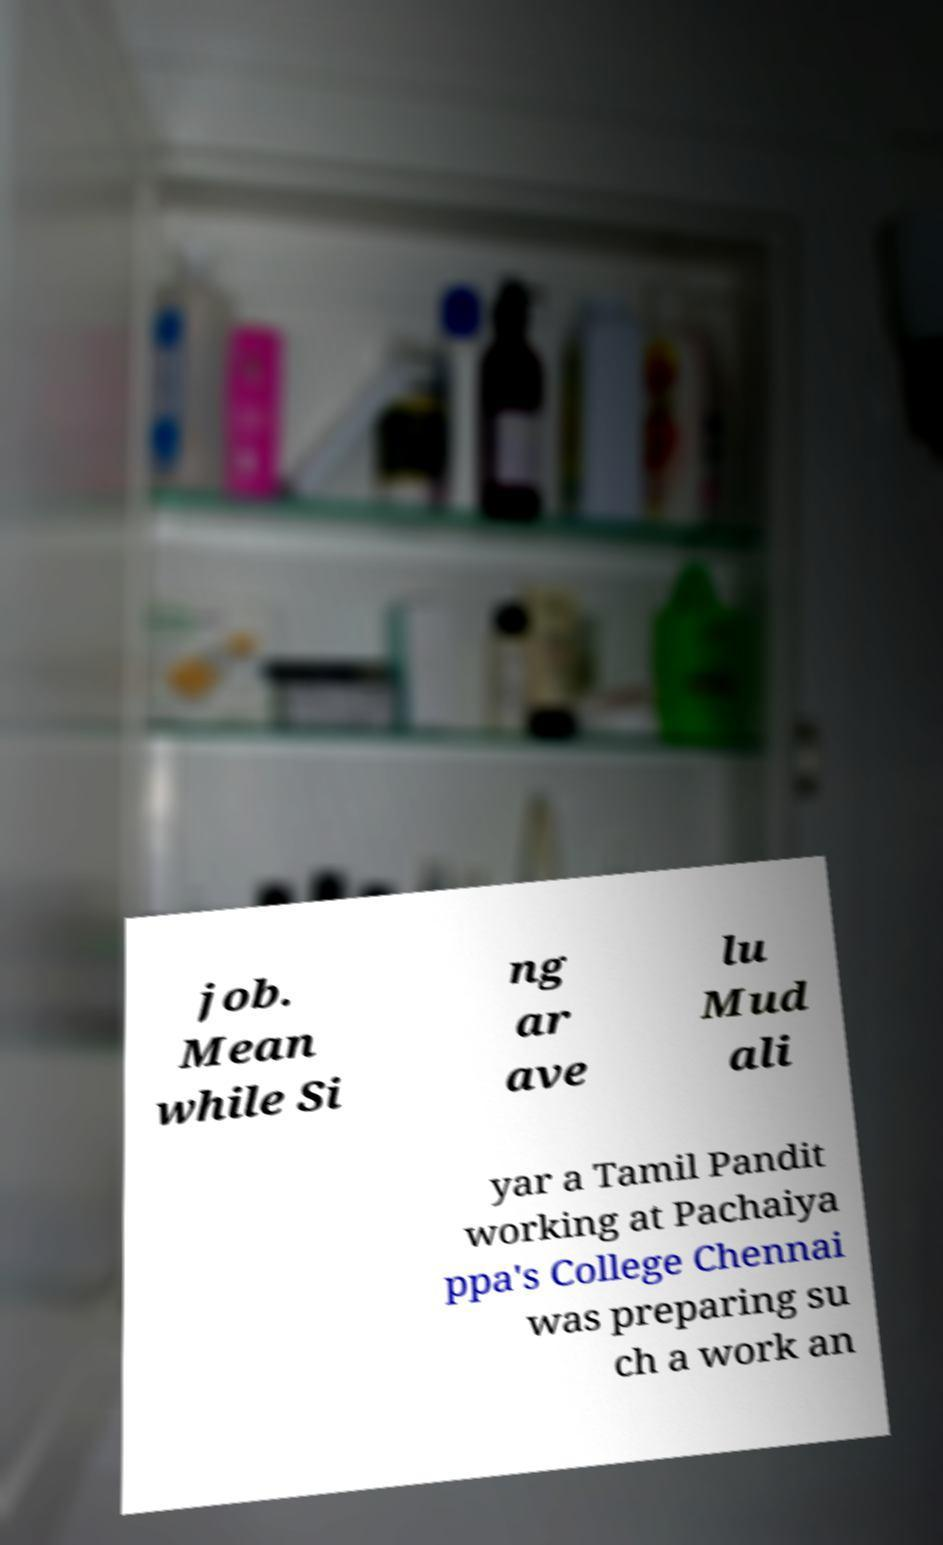Could you assist in decoding the text presented in this image and type it out clearly? job. Mean while Si ng ar ave lu Mud ali yar a Tamil Pandit working at Pachaiya ppa's College Chennai was preparing su ch a work an 